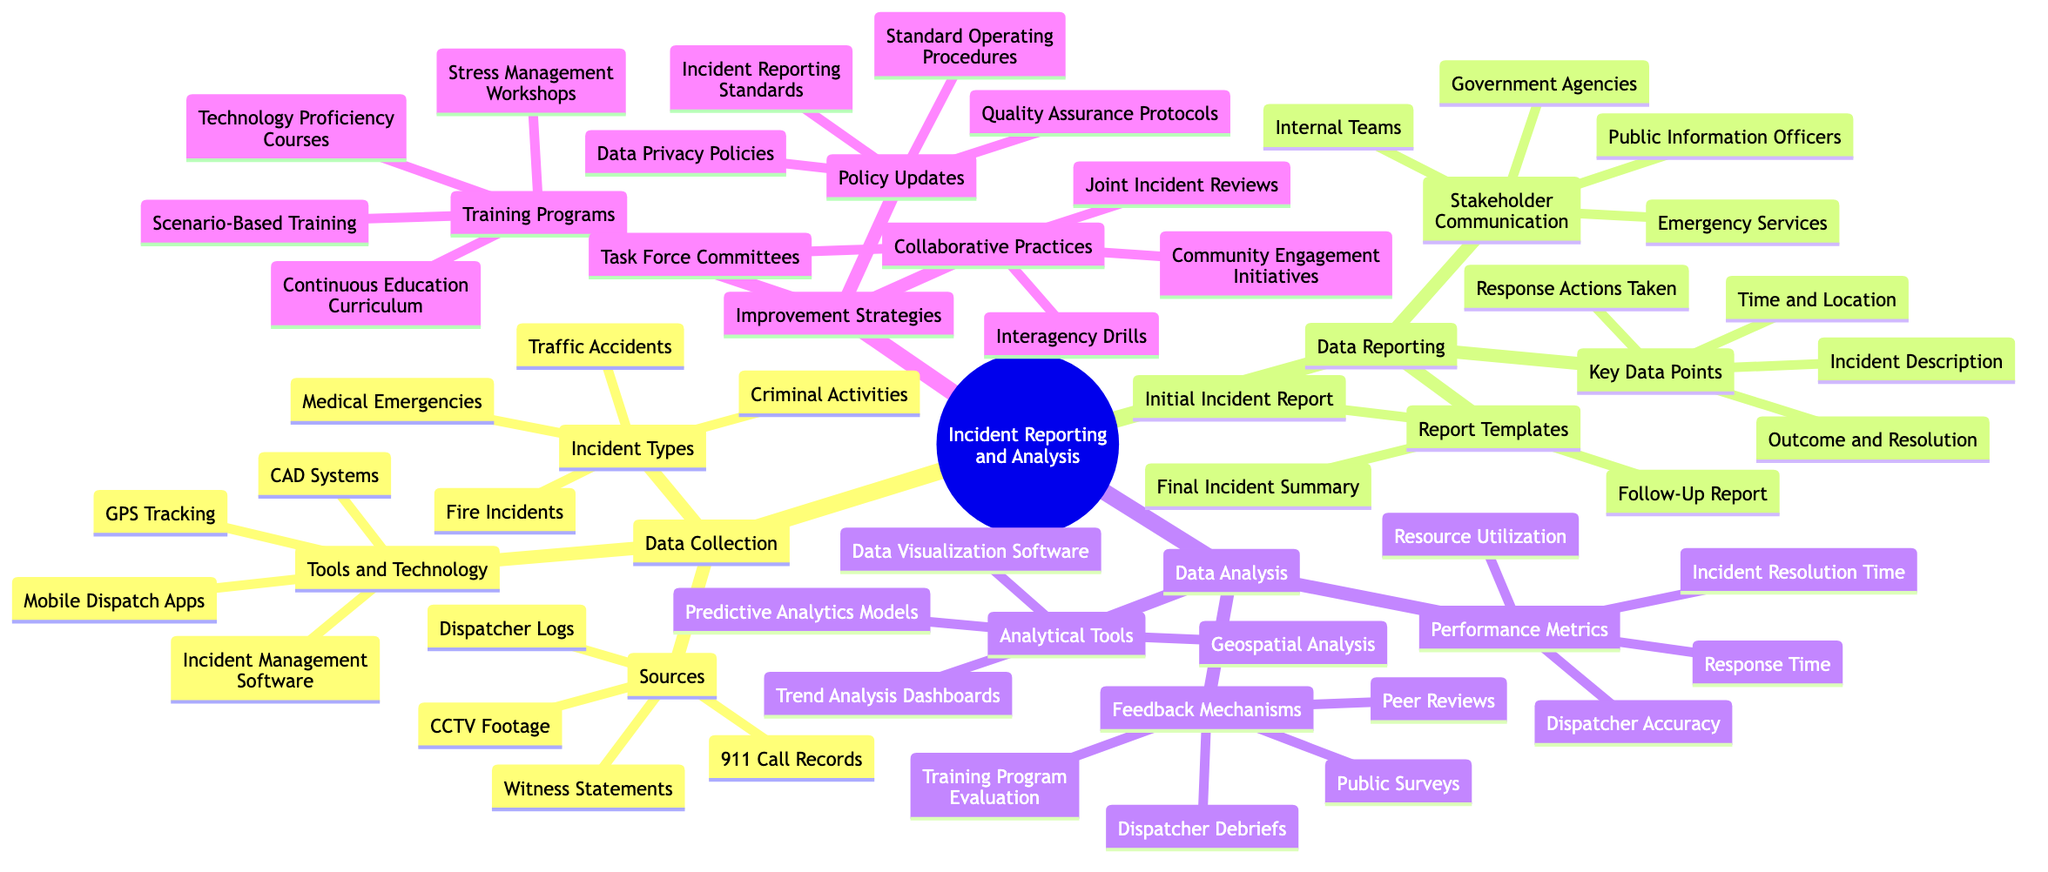What are the four types of incidents listed? The diagram specifies four types of incidents under the "Incident Types" node in the "Data Collection" branch: Traffic Accidents, Medical Emergencies, Fire Incidents, and Criminal Activities.
Answer: Traffic Accidents, Medical Emergencies, Fire Incidents, Criminal Activities How many sources of data are listed? The "Sources" node under "Data Collection" has four items: Dispatcher Logs, 911 Call Records, CCTV Footage, and Witness Statements. This indicates there are four sources of data listed.
Answer: 4 What is one key data point mentioned in the data reporting? The "Key Data Points" node lists several points including Time and Location, Incident Description, Response Actions Taken, and Outcome and Resolution. Therefore, any of these can be considered a key data point.
Answer: Time and Location Which tools are mentioned for data analysis? The "Analytical Tools" node in the "Data Analysis" section contains four tools: Data Visualization Software, Predictive Analytics Models, Geospatial Analysis, and Trend Analysis Dashboards. Thus, there are four tools specifically mentioned for data analysis.
Answer: 4 What types of training programs are included in the improvement strategies section? Under the "Training Programs" node in the "Improvement Strategies," there are four types listed: Scenario-Based Training, Stress Management Workshops, Technology Proficiency Courses, and Continuous Education Curriculum. Therefore, those are the training types included.
Answer: Scenario-Based Training, Stress Management Workshops, Technology Proficiency Courses, Continuous Education Curriculum What is the relationship between Data Collection and Improvement Strategies? The diagram visually organizes "Data Collection" and "Improvement Strategies" as two main categories under the broader concept of "Incident Reporting and Analysis." They are both part of the overall incident management process but focus on different aspects—one on gathering information and the other on enhancing practices based on that information.
Answer: Data Collection focuses on gathering information; Improvement Strategies focus on enhancing practices How many report templates are listed in the data reporting section? The "Report Templates" node in the "Data Reporting" section includes three templates: Initial Incident Report, Follow-Up Report, and Final Incident Summary. Therefore, three report templates are listed.
Answer: 3 Which stakeholder is mentioned as part of stakeholder communication? The "Stakeholder Communication" node lists four stakeholders: Internal Teams, Emergency Services, Public Information Officers, and Government Agencies. Any of these stakeholders is a valid answer, as they are all mentioned in that section.
Answer: Emergency Services What kind of feedback mechanisms are included in data analysis? In the "Feedback Mechanisms" node of "Data Analysis," it lists Dispatcher Debriefs, Training Program Evaluation, Public Surveys, and Peer Reviews. Thus, these are the feedback mechanisms used to improve processes.
Answer: Dispatcher Debriefs, Training Program Evaluation, Public Surveys, Peer Reviews 